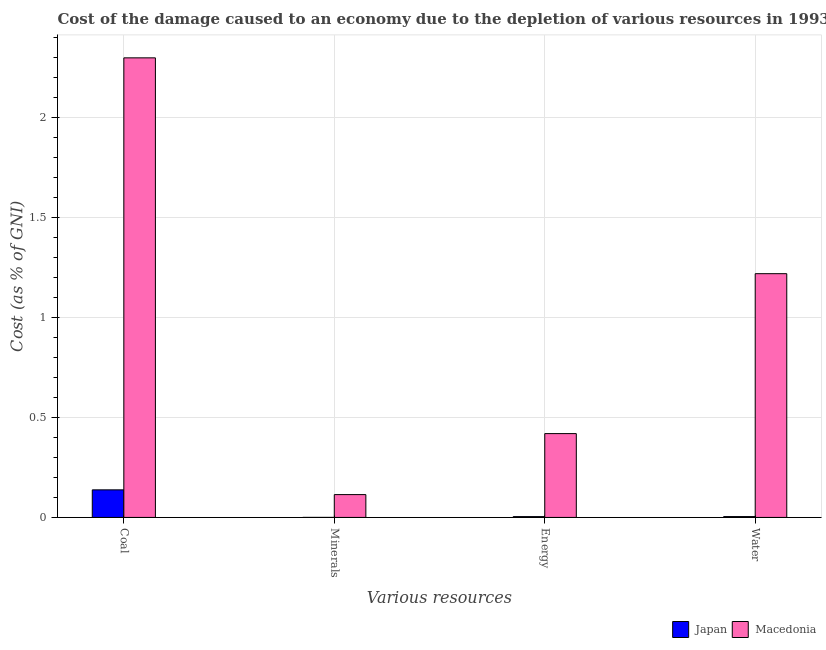How many different coloured bars are there?
Your response must be concise. 2. How many groups of bars are there?
Your answer should be compact. 4. How many bars are there on the 3rd tick from the right?
Make the answer very short. 2. What is the label of the 2nd group of bars from the left?
Make the answer very short. Minerals. What is the cost of damage due to depletion of energy in Macedonia?
Provide a short and direct response. 0.42. Across all countries, what is the maximum cost of damage due to depletion of minerals?
Provide a short and direct response. 0.11. Across all countries, what is the minimum cost of damage due to depletion of energy?
Your response must be concise. 0. In which country was the cost of damage due to depletion of minerals maximum?
Make the answer very short. Macedonia. What is the total cost of damage due to depletion of minerals in the graph?
Your answer should be compact. 0.11. What is the difference between the cost of damage due to depletion of water in Macedonia and that in Japan?
Keep it short and to the point. 1.21. What is the difference between the cost of damage due to depletion of energy in Japan and the cost of damage due to depletion of water in Macedonia?
Make the answer very short. -1.21. What is the average cost of damage due to depletion of minerals per country?
Provide a short and direct response. 0.06. What is the difference between the cost of damage due to depletion of minerals and cost of damage due to depletion of energy in Macedonia?
Your response must be concise. -0.3. What is the ratio of the cost of damage due to depletion of energy in Japan to that in Macedonia?
Give a very brief answer. 0.01. Is the difference between the cost of damage due to depletion of minerals in Macedonia and Japan greater than the difference between the cost of damage due to depletion of energy in Macedonia and Japan?
Give a very brief answer. No. What is the difference between the highest and the second highest cost of damage due to depletion of water?
Offer a terse response. 1.21. What is the difference between the highest and the lowest cost of damage due to depletion of water?
Keep it short and to the point. 1.21. Is it the case that in every country, the sum of the cost of damage due to depletion of energy and cost of damage due to depletion of coal is greater than the sum of cost of damage due to depletion of minerals and cost of damage due to depletion of water?
Offer a terse response. No. What does the 1st bar from the right in Energy represents?
Your response must be concise. Macedonia. Is it the case that in every country, the sum of the cost of damage due to depletion of coal and cost of damage due to depletion of minerals is greater than the cost of damage due to depletion of energy?
Keep it short and to the point. Yes. Does the graph contain any zero values?
Your answer should be compact. No. Does the graph contain grids?
Make the answer very short. Yes. Where does the legend appear in the graph?
Offer a terse response. Bottom right. What is the title of the graph?
Offer a terse response. Cost of the damage caused to an economy due to the depletion of various resources in 1993 . Does "Bahrain" appear as one of the legend labels in the graph?
Your answer should be compact. No. What is the label or title of the X-axis?
Make the answer very short. Various resources. What is the label or title of the Y-axis?
Provide a short and direct response. Cost (as % of GNI). What is the Cost (as % of GNI) of Japan in Coal?
Give a very brief answer. 0.14. What is the Cost (as % of GNI) in Macedonia in Coal?
Offer a very short reply. 2.3. What is the Cost (as % of GNI) of Japan in Minerals?
Make the answer very short. 0. What is the Cost (as % of GNI) of Macedonia in Minerals?
Your answer should be compact. 0.11. What is the Cost (as % of GNI) in Japan in Energy?
Your answer should be compact. 0. What is the Cost (as % of GNI) of Macedonia in Energy?
Ensure brevity in your answer.  0.42. What is the Cost (as % of GNI) of Japan in Water?
Keep it short and to the point. 0. What is the Cost (as % of GNI) in Macedonia in Water?
Offer a terse response. 1.22. Across all Various resources, what is the maximum Cost (as % of GNI) of Japan?
Keep it short and to the point. 0.14. Across all Various resources, what is the maximum Cost (as % of GNI) of Macedonia?
Ensure brevity in your answer.  2.3. Across all Various resources, what is the minimum Cost (as % of GNI) in Japan?
Ensure brevity in your answer.  0. Across all Various resources, what is the minimum Cost (as % of GNI) of Macedonia?
Ensure brevity in your answer.  0.11. What is the total Cost (as % of GNI) in Japan in the graph?
Provide a short and direct response. 0.15. What is the total Cost (as % of GNI) of Macedonia in the graph?
Your answer should be very brief. 4.05. What is the difference between the Cost (as % of GNI) in Japan in Coal and that in Minerals?
Your answer should be compact. 0.14. What is the difference between the Cost (as % of GNI) in Macedonia in Coal and that in Minerals?
Make the answer very short. 2.18. What is the difference between the Cost (as % of GNI) in Japan in Coal and that in Energy?
Provide a short and direct response. 0.13. What is the difference between the Cost (as % of GNI) of Macedonia in Coal and that in Energy?
Offer a terse response. 1.88. What is the difference between the Cost (as % of GNI) in Japan in Coal and that in Water?
Your response must be concise. 0.13. What is the difference between the Cost (as % of GNI) of Macedonia in Coal and that in Water?
Offer a very short reply. 1.08. What is the difference between the Cost (as % of GNI) in Japan in Minerals and that in Energy?
Your response must be concise. -0. What is the difference between the Cost (as % of GNI) in Macedonia in Minerals and that in Energy?
Your answer should be compact. -0.3. What is the difference between the Cost (as % of GNI) in Japan in Minerals and that in Water?
Offer a terse response. -0. What is the difference between the Cost (as % of GNI) of Macedonia in Minerals and that in Water?
Offer a terse response. -1.1. What is the difference between the Cost (as % of GNI) of Japan in Energy and that in Water?
Your response must be concise. -0. What is the difference between the Cost (as % of GNI) of Macedonia in Energy and that in Water?
Your response must be concise. -0.8. What is the difference between the Cost (as % of GNI) of Japan in Coal and the Cost (as % of GNI) of Macedonia in Minerals?
Provide a succinct answer. 0.02. What is the difference between the Cost (as % of GNI) in Japan in Coal and the Cost (as % of GNI) in Macedonia in Energy?
Give a very brief answer. -0.28. What is the difference between the Cost (as % of GNI) of Japan in Coal and the Cost (as % of GNI) of Macedonia in Water?
Ensure brevity in your answer.  -1.08. What is the difference between the Cost (as % of GNI) in Japan in Minerals and the Cost (as % of GNI) in Macedonia in Energy?
Make the answer very short. -0.42. What is the difference between the Cost (as % of GNI) of Japan in Minerals and the Cost (as % of GNI) of Macedonia in Water?
Make the answer very short. -1.22. What is the difference between the Cost (as % of GNI) of Japan in Energy and the Cost (as % of GNI) of Macedonia in Water?
Keep it short and to the point. -1.21. What is the average Cost (as % of GNI) in Japan per Various resources?
Give a very brief answer. 0.04. What is the average Cost (as % of GNI) of Macedonia per Various resources?
Your answer should be compact. 1.01. What is the difference between the Cost (as % of GNI) in Japan and Cost (as % of GNI) in Macedonia in Coal?
Ensure brevity in your answer.  -2.16. What is the difference between the Cost (as % of GNI) of Japan and Cost (as % of GNI) of Macedonia in Minerals?
Keep it short and to the point. -0.11. What is the difference between the Cost (as % of GNI) in Japan and Cost (as % of GNI) in Macedonia in Energy?
Offer a terse response. -0.41. What is the difference between the Cost (as % of GNI) in Japan and Cost (as % of GNI) in Macedonia in Water?
Offer a very short reply. -1.21. What is the ratio of the Cost (as % of GNI) of Japan in Coal to that in Minerals?
Your response must be concise. 863.65. What is the ratio of the Cost (as % of GNI) in Macedonia in Coal to that in Minerals?
Provide a short and direct response. 20.13. What is the ratio of the Cost (as % of GNI) in Japan in Coal to that in Energy?
Give a very brief answer. 34.05. What is the ratio of the Cost (as % of GNI) in Macedonia in Coal to that in Energy?
Your response must be concise. 5.48. What is the ratio of the Cost (as % of GNI) of Japan in Coal to that in Water?
Keep it short and to the point. 32.76. What is the ratio of the Cost (as % of GNI) in Macedonia in Coal to that in Water?
Provide a succinct answer. 1.89. What is the ratio of the Cost (as % of GNI) of Japan in Minerals to that in Energy?
Give a very brief answer. 0.04. What is the ratio of the Cost (as % of GNI) of Macedonia in Minerals to that in Energy?
Keep it short and to the point. 0.27. What is the ratio of the Cost (as % of GNI) of Japan in Minerals to that in Water?
Keep it short and to the point. 0.04. What is the ratio of the Cost (as % of GNI) of Macedonia in Minerals to that in Water?
Offer a terse response. 0.09. What is the ratio of the Cost (as % of GNI) of Japan in Energy to that in Water?
Keep it short and to the point. 0.96. What is the ratio of the Cost (as % of GNI) of Macedonia in Energy to that in Water?
Provide a succinct answer. 0.34. What is the difference between the highest and the second highest Cost (as % of GNI) in Japan?
Your response must be concise. 0.13. What is the difference between the highest and the second highest Cost (as % of GNI) in Macedonia?
Ensure brevity in your answer.  1.08. What is the difference between the highest and the lowest Cost (as % of GNI) of Japan?
Your response must be concise. 0.14. What is the difference between the highest and the lowest Cost (as % of GNI) of Macedonia?
Give a very brief answer. 2.18. 